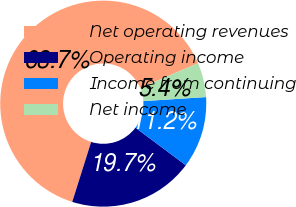Convert chart to OTSL. <chart><loc_0><loc_0><loc_500><loc_500><pie_chart><fcel>Net operating revenues<fcel>Operating income<fcel>Income from continuing<fcel>Net income<nl><fcel>63.74%<fcel>19.66%<fcel>11.22%<fcel>5.39%<nl></chart> 